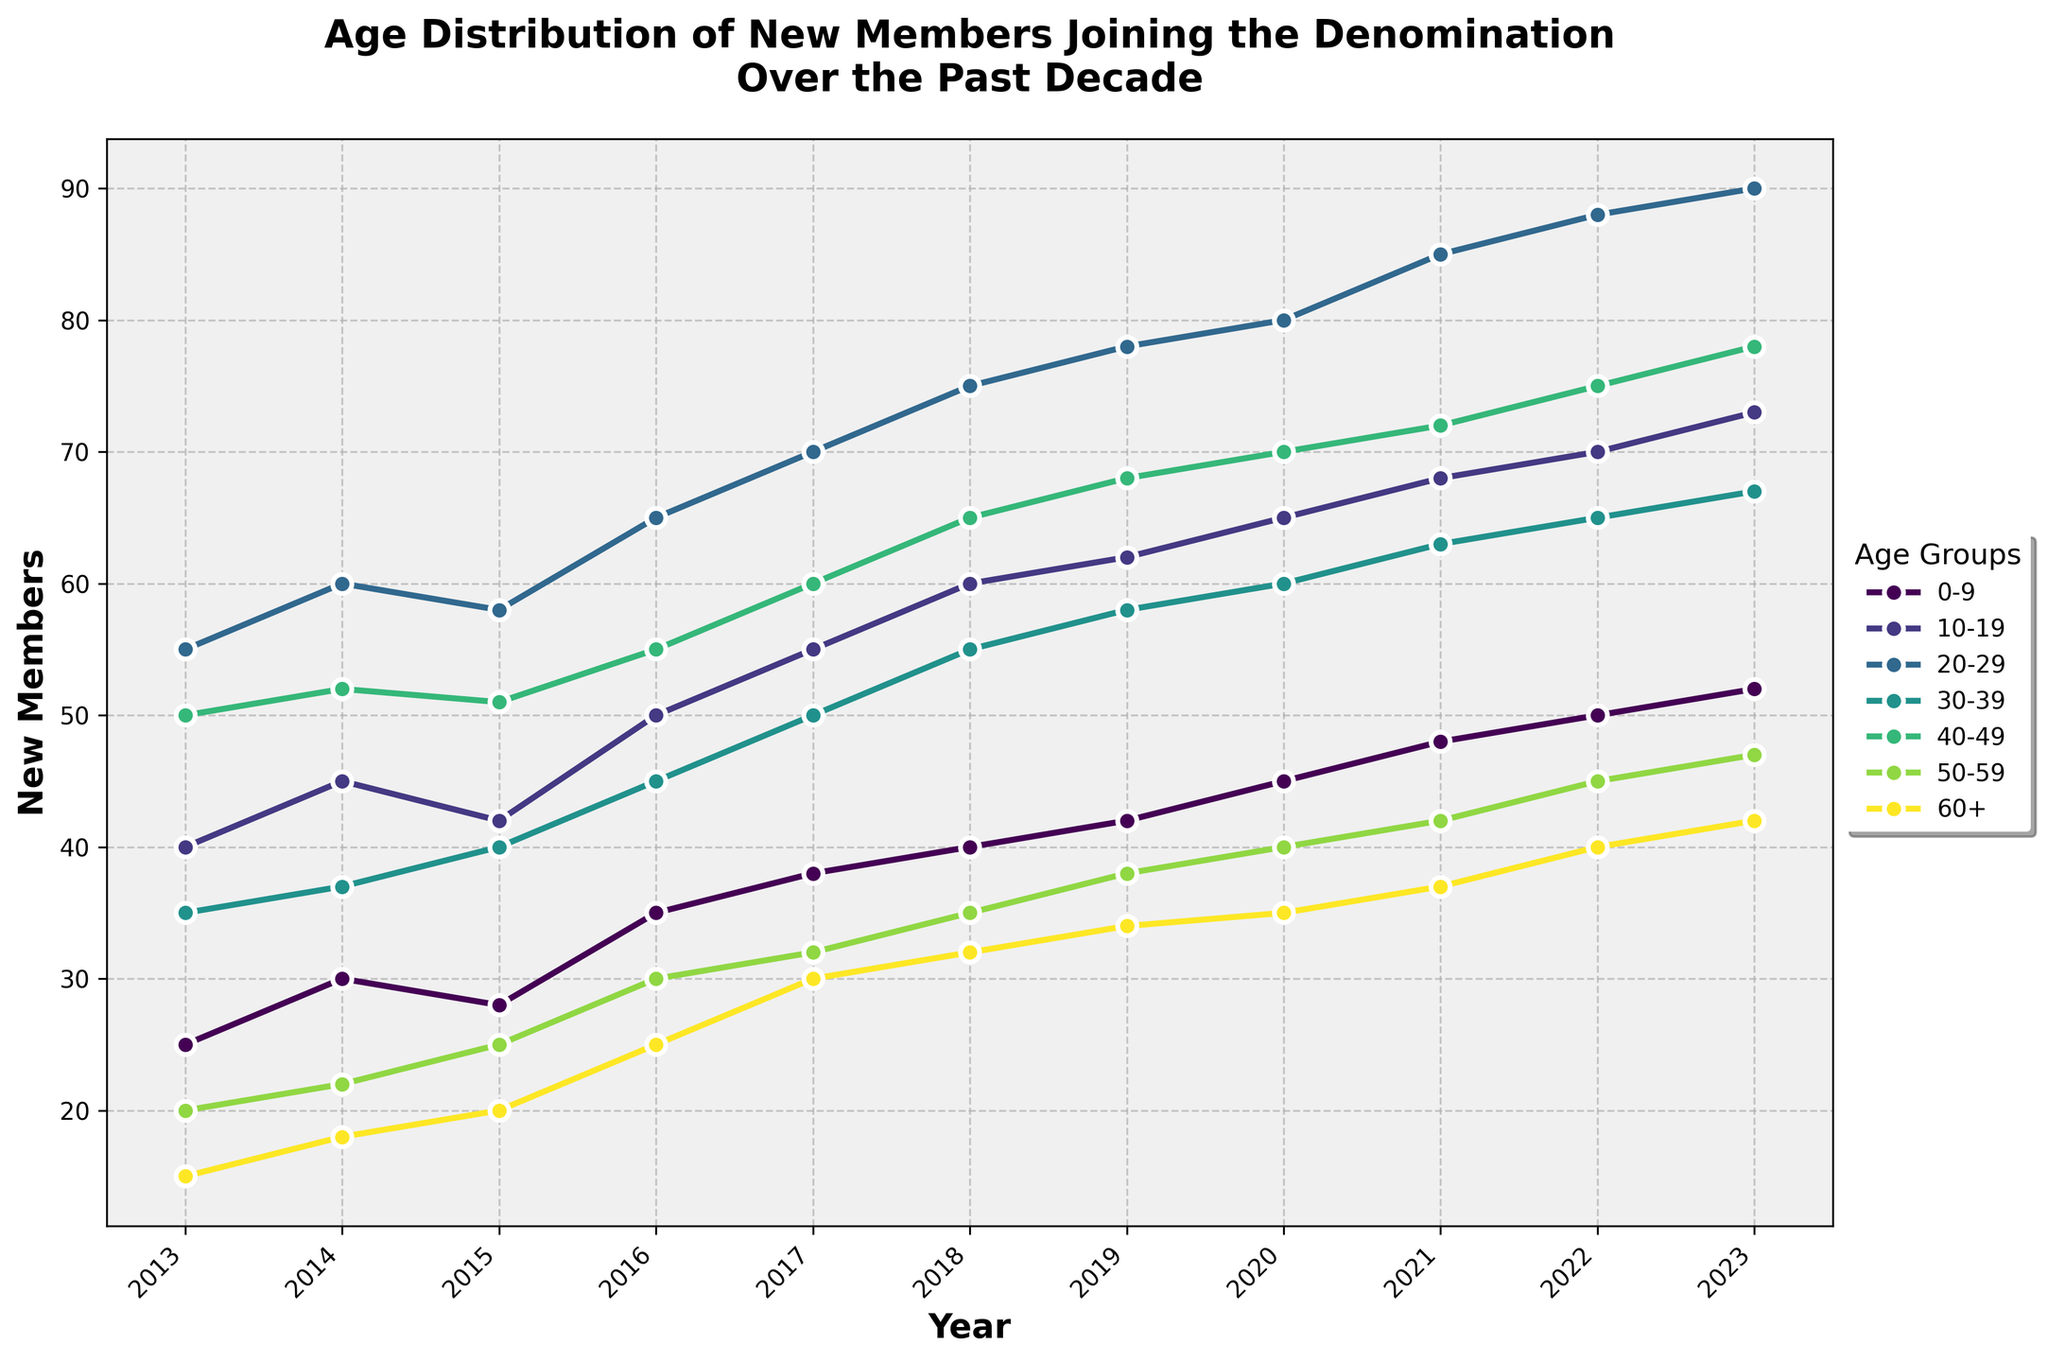What is the title of the figure? The figure's title is usually found at the top of the plot. It is a descriptive heading summarizing the visualization.
Answer: "Age Distribution of New Members Joining the Denomination Over the Past Decade" What is the color of the line representing the 20-29 age group? The color of the line can be determined by matching the legend description with the corresponding line on the plot. The colors are from a predefined palette.
Answer: Green (or the specific shade used in the plot) How many total new members joined in 2020? Sum up the values of new members for each age group in the year 2020. This involves adding the counts for each listed age group for that specific year.
Answer: 395 Which age group had the highest number of new members in 2023? Analyze the plot to identify the highest point on the vertical axis for the year 2023. Then, refer to the legend to determine the corresponding age group.
Answer: 20-29 What is the trend for the number of new members in the 60+ age group from 2016 to 2023? Follow the plotted line for the 60+ age group across the years 2016 to 2023. Observe whether the line is generally increasing, decreasing, or remaining stable.
Answer: Increasing How does the number of new members in the 40-49 age group in 2017 compare to that in 2023? Locate the points for the 40-49 age group in the years 2017 and 2023 on the plot. Compare their values to see the difference.
Answer: In 2023, it is higher What's the difference in the number of new members between the 10-19 and 50-59 age groups in 2022? Find the values for both age groups in 2022. Subtract the number of new members in the 50-59 age group from the number in the 10-19 age group.
Answer: 25 Which age group consistently shows an increasing trend in the number of new members from 2013 to 2023? For each age group, follow their respective lines on the plot from 2013 to 2023 and note if the line is consistently moving upwards.
Answer: 0-9 